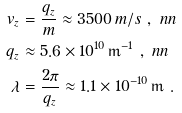<formula> <loc_0><loc_0><loc_500><loc_500>v _ { z } & = \frac { q _ { z } } { m } \approx 3 5 0 0 \, m / s \ , \ n n \\ q _ { z } & \approx 5 . 6 \times 1 0 ^ { 1 0 } \, \mathrm m ^ { - 1 } \ , \ n n \\ \lambda & = \frac { 2 \pi } { q _ { z } } \approx 1 . 1 \times 1 0 ^ { - 1 0 } \, \mathrm m \ .</formula> 